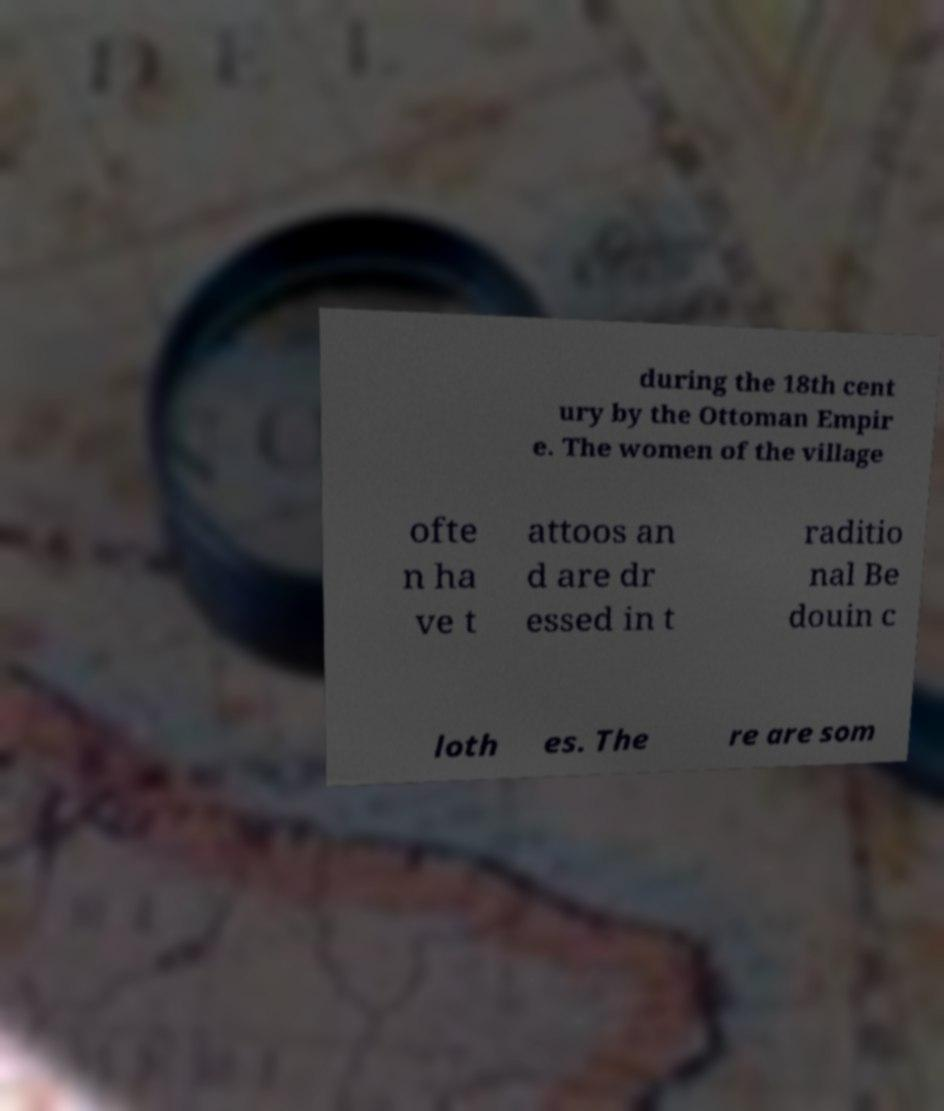Could you extract and type out the text from this image? during the 18th cent ury by the Ottoman Empir e. The women of the village ofte n ha ve t attoos an d are dr essed in t raditio nal Be douin c loth es. The re are som 